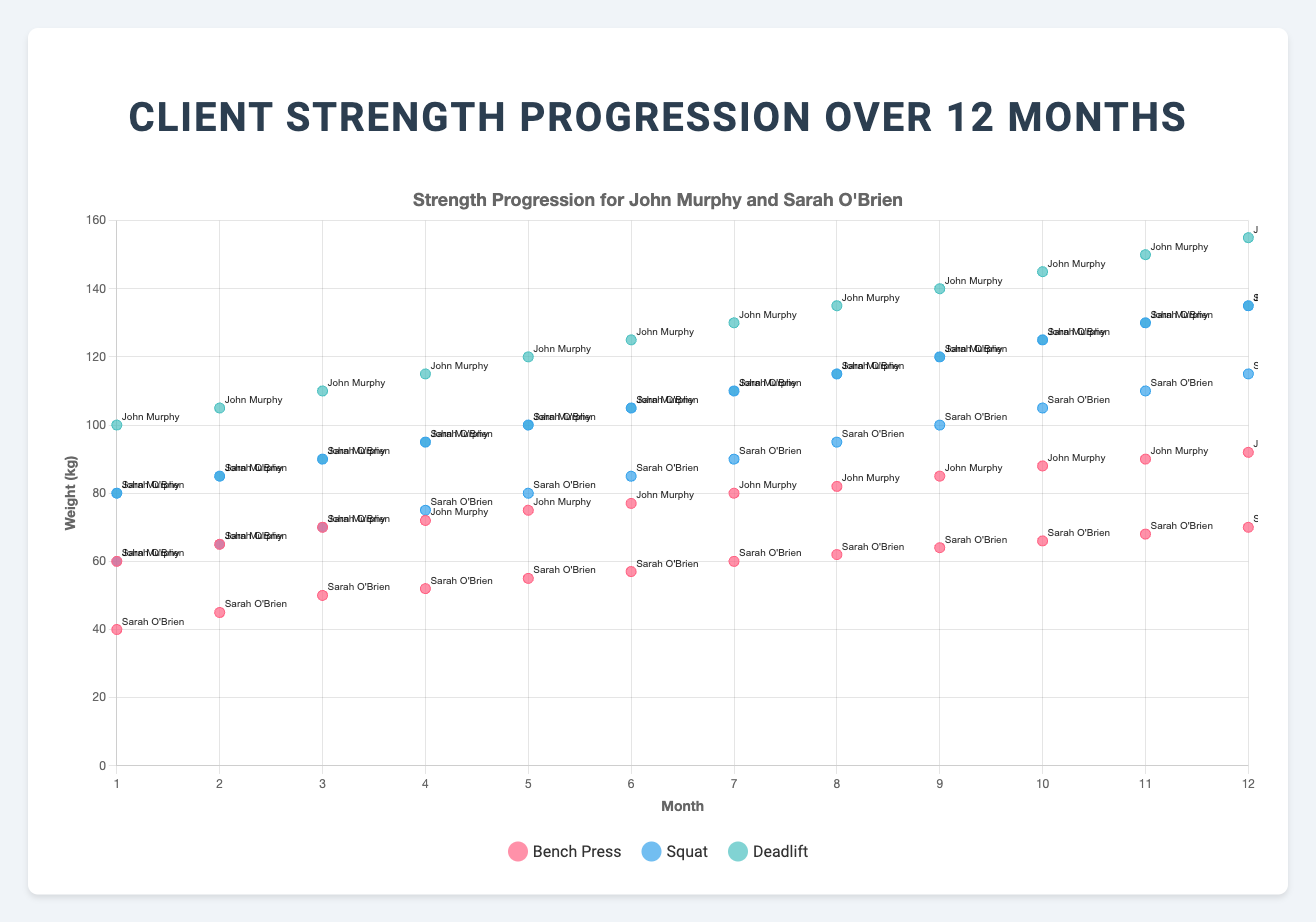What's the title of the figure? The title is typically found at the top of the figure. In this case, it's "Strength Progression for John Murphy and Sarah O'Brien," as described in the code
Answer: Strength Progression for John Murphy and Sarah O'Brien What does the x-axis represent? The x-axis label is "Month," indicating the progression of time in months from 1 to 12
Answer: Month What does the y-axis represent? The y-axis label is "Weight (kg)," indicating the weights lifted in kilograms for different exercises
Answer: Weight (kg) Which color represents the Bench Press data points? The legend associated with the figure indicates that the Bench Press data points are represented by a red color
Answer: Red By how many kilograms did John Murphy's bench press increase from month 1 to month 12? Look for John Murphy's Bench Press data points at month 1 and month 12. They are 60 kg and 92 kg, respectively. The difference is 92 kg - 60 kg = 32 kg
Answer: 32 kg Which client had the greatest increase in their squat over the 12 months? Compare the squat increases of both clients from month 1 to month 12. John Murphy's squat increased from 80 kg to 135 kg (55 kg), while Sarah O'Brien's squat increased from 60 kg to 115 kg (55 kg). Both clients had the same increase
Answer: Both John Murphy and Sarah O'Brien What is the average bench press weight in month 6 for both clients combined? Add the bench press weights of both clients in month 6 and divide by 2. John Murphy's bench press is 77 kg, and Sarah O'Brien's is 57 kg: (77 kg + 57 kg) / 2 = 67 kg
Answer: 67 kg Between which months did Sarah O'Brien have the largest monthly increase in her deadlift? Calculate the month-to-month differences in Sarah O'Brien's deadlift. The largest increase occurs between month 3 (90 kg) and month 4 (95 kg), showing a 5 kg increase
Answer: Between months 3 and 4 What is the overall trend in John Murphy's deadlift performance over the 12 months? The trendline and data points show a consistent increase from 100 kg in month 1 to 155 kg in month 12
Answer: Consistently increasing How do the trends in bench press progression compare between John Murphy and Sarah O'Brien over 12 months? Both John Murphy and Sarah O'Brien show an increasing trend, but John Murphy's increases more steeply from 60 kg to 92 kg, while Sarah O'Brien's goes from 40 kg to 70 kg. John Murphy's progression is steeper and ends at a higher weight
Answer: John Murphy's progression is steeper and ends higher 